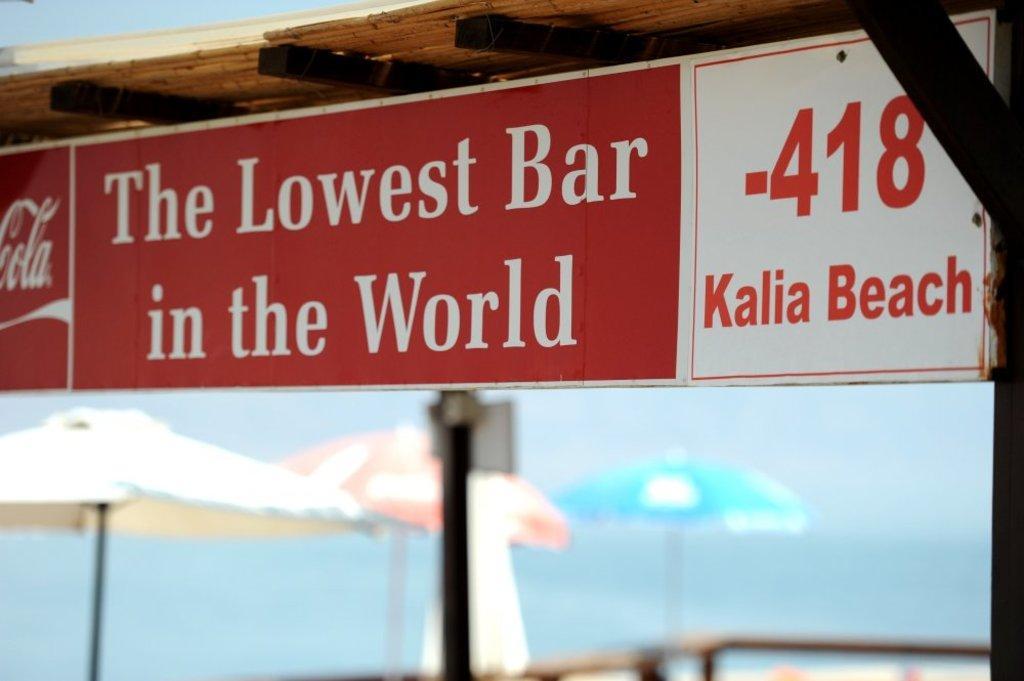Can you describe this image briefly? This image consists of a board fixed to the roof. In the background, we can see three umbrellas. And there is a text on the board. 